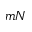Convert formula to latex. <formula><loc_0><loc_0><loc_500><loc_500>m N</formula> 